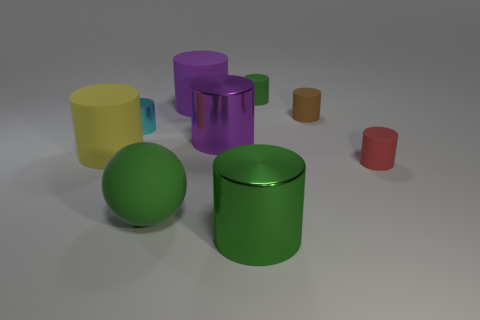What is the size of the metal object that is the same color as the big sphere?
Give a very brief answer. Large. How many things are small green cylinders or big rubber objects?
Your response must be concise. 4. What shape is the large matte thing that is both right of the tiny cyan cylinder and in front of the brown matte cylinder?
Offer a terse response. Sphere. Do the tiny brown object and the big matte object that is to the right of the matte sphere have the same shape?
Offer a very short reply. Yes. Are there any large rubber cylinders behind the large purple shiny cylinder?
Ensure brevity in your answer.  Yes. There is a big thing that is the same color as the big rubber sphere; what is it made of?
Your answer should be compact. Metal. How many balls are either tiny cyan shiny objects or brown objects?
Your response must be concise. 0. Does the tiny red matte thing have the same shape as the tiny shiny object?
Your response must be concise. Yes. How big is the green thing behind the yellow matte object?
Your answer should be very brief. Small. Are there any things of the same color as the matte ball?
Keep it short and to the point. Yes. 